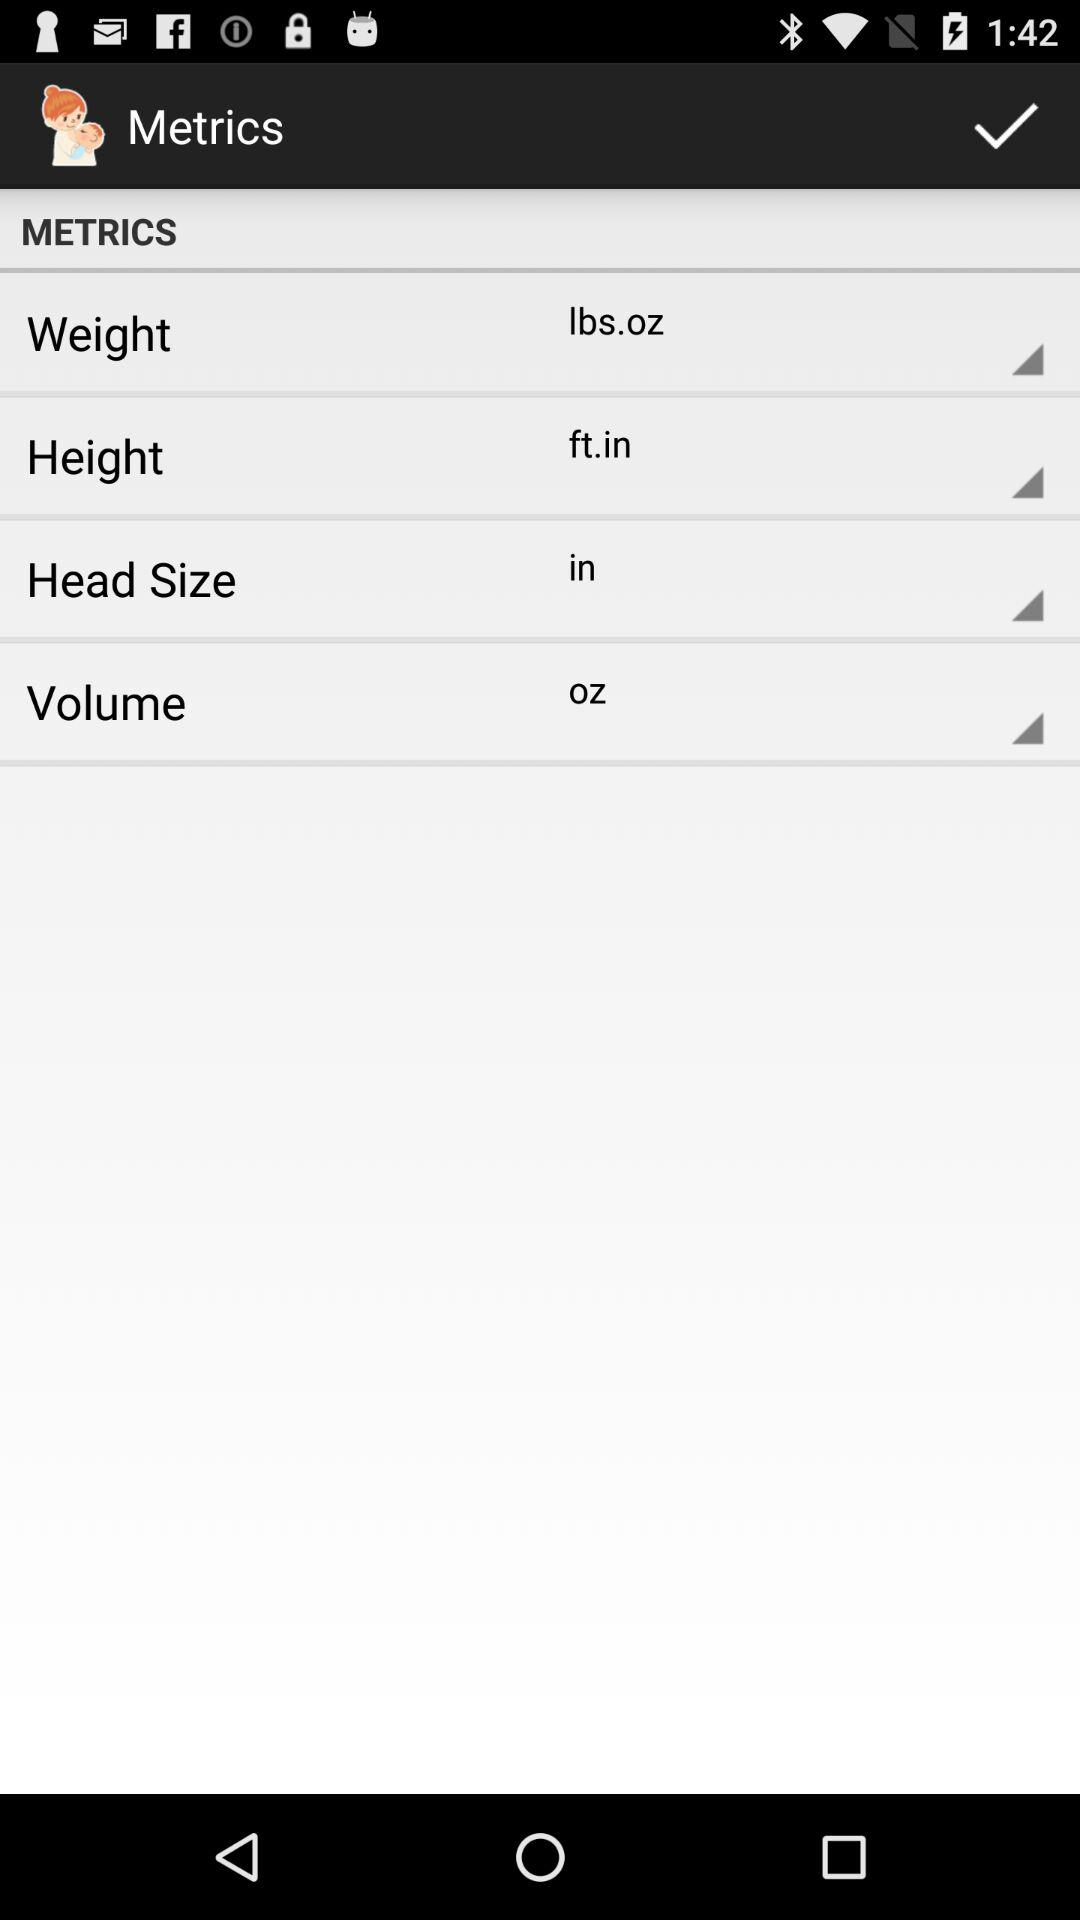What is the unit of weight? The unit of weight is lbs.oz. 